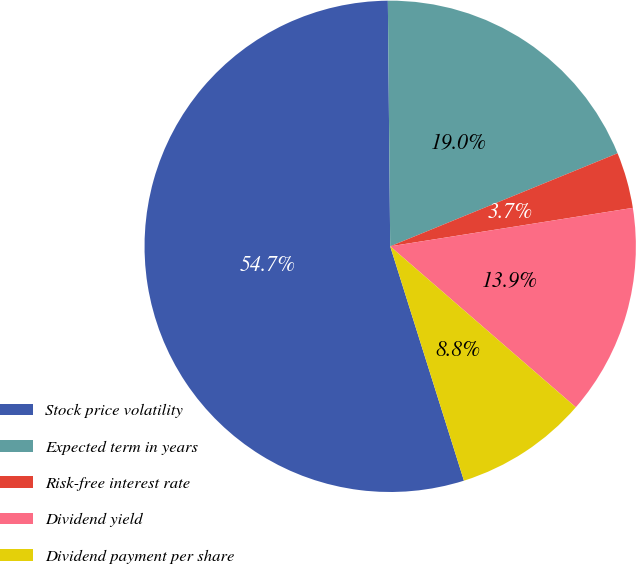Convert chart. <chart><loc_0><loc_0><loc_500><loc_500><pie_chart><fcel>Stock price volatility<fcel>Expected term in years<fcel>Risk-free interest rate<fcel>Dividend yield<fcel>Dividend payment per share<nl><fcel>54.7%<fcel>18.97%<fcel>3.68%<fcel>13.87%<fcel>8.78%<nl></chart> 